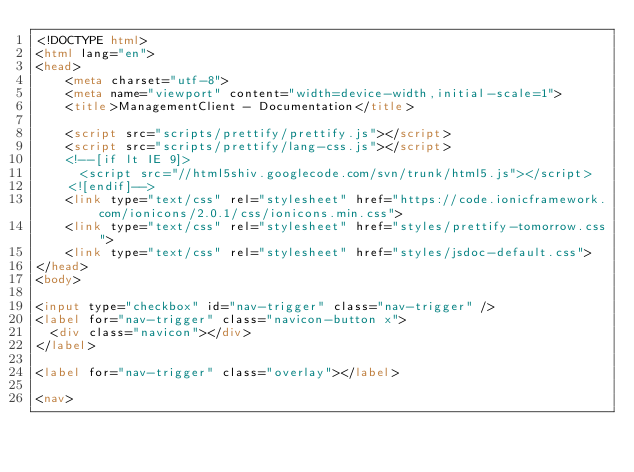Convert code to text. <code><loc_0><loc_0><loc_500><loc_500><_HTML_><!DOCTYPE html>
<html lang="en">
<head>
    <meta charset="utf-8">
    <meta name="viewport" content="width=device-width,initial-scale=1">
    <title>ManagementClient - Documentation</title>

    <script src="scripts/prettify/prettify.js"></script>
    <script src="scripts/prettify/lang-css.js"></script>
    <!--[if lt IE 9]>
      <script src="//html5shiv.googlecode.com/svn/trunk/html5.js"></script>
    <![endif]-->
    <link type="text/css" rel="stylesheet" href="https://code.ionicframework.com/ionicons/2.0.1/css/ionicons.min.css">
    <link type="text/css" rel="stylesheet" href="styles/prettify-tomorrow.css">
    <link type="text/css" rel="stylesheet" href="styles/jsdoc-default.css">
</head>
<body>

<input type="checkbox" id="nav-trigger" class="nav-trigger" />
<label for="nav-trigger" class="navicon-button x">
  <div class="navicon"></div>
</label>

<label for="nav-trigger" class="overlay"></label>

<nav></code> 